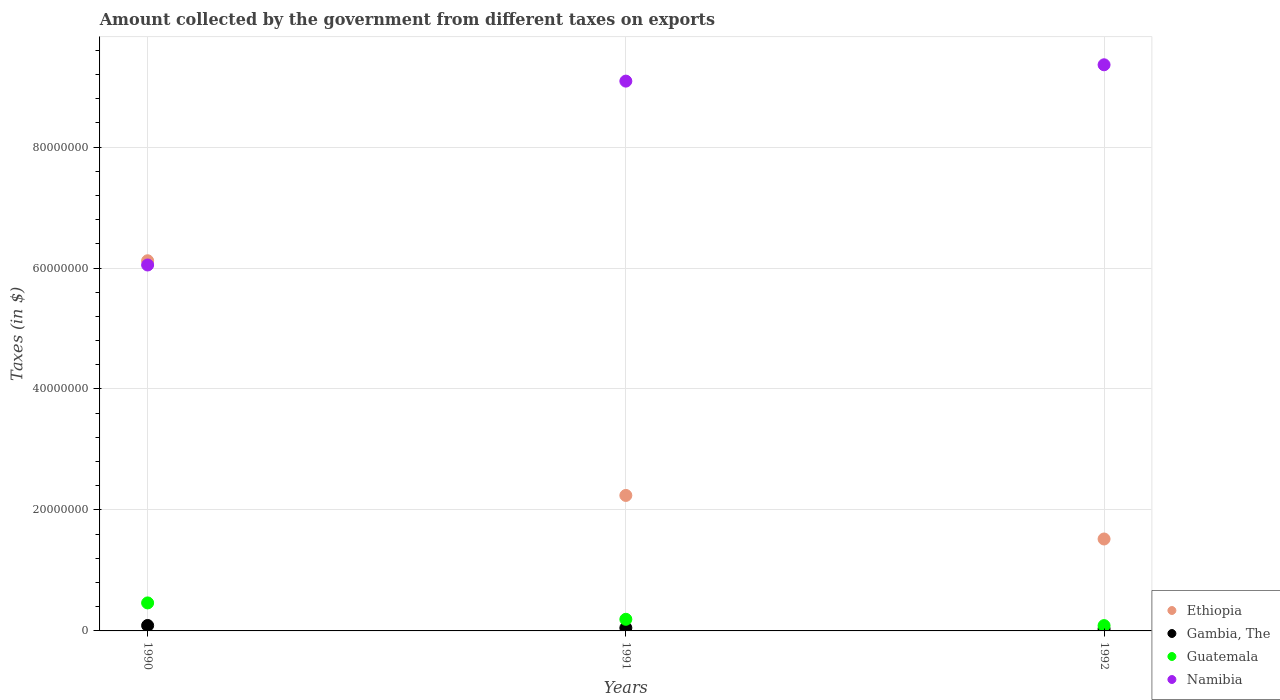Is the number of dotlines equal to the number of legend labels?
Provide a succinct answer. Yes. What is the amount collected by the government from taxes on exports in Ethiopia in 1990?
Make the answer very short. 6.12e+07. Across all years, what is the maximum amount collected by the government from taxes on exports in Gambia, The?
Give a very brief answer. 9.00e+05. Across all years, what is the minimum amount collected by the government from taxes on exports in Guatemala?
Your answer should be compact. 8.80e+05. In which year was the amount collected by the government from taxes on exports in Namibia maximum?
Keep it short and to the point. 1992. What is the total amount collected by the government from taxes on exports in Ethiopia in the graph?
Your response must be concise. 9.88e+07. What is the difference between the amount collected by the government from taxes on exports in Gambia, The in 1990 and that in 1991?
Your answer should be compact. 4.00e+05. What is the difference between the amount collected by the government from taxes on exports in Guatemala in 1992 and the amount collected by the government from taxes on exports in Namibia in 1990?
Keep it short and to the point. -5.96e+07. What is the average amount collected by the government from taxes on exports in Namibia per year?
Ensure brevity in your answer.  8.17e+07. In the year 1992, what is the difference between the amount collected by the government from taxes on exports in Guatemala and amount collected by the government from taxes on exports in Namibia?
Offer a terse response. -9.27e+07. What is the ratio of the amount collected by the government from taxes on exports in Namibia in 1990 to that in 1992?
Provide a succinct answer. 0.65. Is the difference between the amount collected by the government from taxes on exports in Guatemala in 1990 and 1991 greater than the difference between the amount collected by the government from taxes on exports in Namibia in 1990 and 1991?
Offer a terse response. Yes. What is the difference between the highest and the second highest amount collected by the government from taxes on exports in Namibia?
Your answer should be very brief. 2.70e+06. What is the difference between the highest and the lowest amount collected by the government from taxes on exports in Namibia?
Offer a very short reply. 3.31e+07. In how many years, is the amount collected by the government from taxes on exports in Guatemala greater than the average amount collected by the government from taxes on exports in Guatemala taken over all years?
Ensure brevity in your answer.  1. Is the sum of the amount collected by the government from taxes on exports in Namibia in 1990 and 1992 greater than the maximum amount collected by the government from taxes on exports in Gambia, The across all years?
Ensure brevity in your answer.  Yes. Is the amount collected by the government from taxes on exports in Ethiopia strictly greater than the amount collected by the government from taxes on exports in Namibia over the years?
Make the answer very short. No. Is the amount collected by the government from taxes on exports in Ethiopia strictly less than the amount collected by the government from taxes on exports in Namibia over the years?
Ensure brevity in your answer.  No. What is the difference between two consecutive major ticks on the Y-axis?
Your answer should be compact. 2.00e+07. Does the graph contain any zero values?
Your answer should be compact. No. What is the title of the graph?
Offer a very short reply. Amount collected by the government from different taxes on exports. What is the label or title of the Y-axis?
Your answer should be compact. Taxes (in $). What is the Taxes (in $) of Ethiopia in 1990?
Make the answer very short. 6.12e+07. What is the Taxes (in $) in Guatemala in 1990?
Provide a short and direct response. 4.63e+06. What is the Taxes (in $) of Namibia in 1990?
Ensure brevity in your answer.  6.05e+07. What is the Taxes (in $) in Ethiopia in 1991?
Make the answer very short. 2.24e+07. What is the Taxes (in $) of Gambia, The in 1991?
Provide a short and direct response. 5.00e+05. What is the Taxes (in $) in Guatemala in 1991?
Give a very brief answer. 1.92e+06. What is the Taxes (in $) of Namibia in 1991?
Offer a terse response. 9.09e+07. What is the Taxes (in $) of Ethiopia in 1992?
Offer a very short reply. 1.52e+07. What is the Taxes (in $) of Guatemala in 1992?
Provide a succinct answer. 8.80e+05. What is the Taxes (in $) in Namibia in 1992?
Your response must be concise. 9.36e+07. Across all years, what is the maximum Taxes (in $) of Ethiopia?
Provide a short and direct response. 6.12e+07. Across all years, what is the maximum Taxes (in $) of Guatemala?
Keep it short and to the point. 4.63e+06. Across all years, what is the maximum Taxes (in $) of Namibia?
Provide a short and direct response. 9.36e+07. Across all years, what is the minimum Taxes (in $) in Ethiopia?
Your answer should be compact. 1.52e+07. Across all years, what is the minimum Taxes (in $) of Guatemala?
Give a very brief answer. 8.80e+05. Across all years, what is the minimum Taxes (in $) of Namibia?
Your answer should be very brief. 6.05e+07. What is the total Taxes (in $) of Ethiopia in the graph?
Give a very brief answer. 9.88e+07. What is the total Taxes (in $) in Gambia, The in the graph?
Offer a very short reply. 1.72e+06. What is the total Taxes (in $) in Guatemala in the graph?
Give a very brief answer. 7.43e+06. What is the total Taxes (in $) of Namibia in the graph?
Provide a succinct answer. 2.45e+08. What is the difference between the Taxes (in $) in Ethiopia in 1990 and that in 1991?
Offer a very short reply. 3.88e+07. What is the difference between the Taxes (in $) in Gambia, The in 1990 and that in 1991?
Keep it short and to the point. 4.00e+05. What is the difference between the Taxes (in $) of Guatemala in 1990 and that in 1991?
Offer a very short reply. 2.71e+06. What is the difference between the Taxes (in $) of Namibia in 1990 and that in 1991?
Ensure brevity in your answer.  -3.04e+07. What is the difference between the Taxes (in $) in Ethiopia in 1990 and that in 1992?
Your answer should be compact. 4.60e+07. What is the difference between the Taxes (in $) of Gambia, The in 1990 and that in 1992?
Offer a terse response. 5.80e+05. What is the difference between the Taxes (in $) in Guatemala in 1990 and that in 1992?
Your response must be concise. 3.75e+06. What is the difference between the Taxes (in $) of Namibia in 1990 and that in 1992?
Provide a short and direct response. -3.31e+07. What is the difference between the Taxes (in $) of Ethiopia in 1991 and that in 1992?
Your answer should be compact. 7.20e+06. What is the difference between the Taxes (in $) in Gambia, The in 1991 and that in 1992?
Make the answer very short. 1.80e+05. What is the difference between the Taxes (in $) of Guatemala in 1991 and that in 1992?
Offer a very short reply. 1.04e+06. What is the difference between the Taxes (in $) of Namibia in 1991 and that in 1992?
Provide a succinct answer. -2.70e+06. What is the difference between the Taxes (in $) of Ethiopia in 1990 and the Taxes (in $) of Gambia, The in 1991?
Your answer should be very brief. 6.07e+07. What is the difference between the Taxes (in $) of Ethiopia in 1990 and the Taxes (in $) of Guatemala in 1991?
Offer a terse response. 5.93e+07. What is the difference between the Taxes (in $) in Ethiopia in 1990 and the Taxes (in $) in Namibia in 1991?
Provide a succinct answer. -2.97e+07. What is the difference between the Taxes (in $) in Gambia, The in 1990 and the Taxes (in $) in Guatemala in 1991?
Provide a short and direct response. -1.02e+06. What is the difference between the Taxes (in $) of Gambia, The in 1990 and the Taxes (in $) of Namibia in 1991?
Ensure brevity in your answer.  -9.00e+07. What is the difference between the Taxes (in $) of Guatemala in 1990 and the Taxes (in $) of Namibia in 1991?
Provide a succinct answer. -8.63e+07. What is the difference between the Taxes (in $) of Ethiopia in 1990 and the Taxes (in $) of Gambia, The in 1992?
Offer a very short reply. 6.09e+07. What is the difference between the Taxes (in $) in Ethiopia in 1990 and the Taxes (in $) in Guatemala in 1992?
Provide a succinct answer. 6.03e+07. What is the difference between the Taxes (in $) of Ethiopia in 1990 and the Taxes (in $) of Namibia in 1992?
Provide a succinct answer. -3.24e+07. What is the difference between the Taxes (in $) of Gambia, The in 1990 and the Taxes (in $) of Guatemala in 1992?
Your response must be concise. 2.00e+04. What is the difference between the Taxes (in $) in Gambia, The in 1990 and the Taxes (in $) in Namibia in 1992?
Offer a very short reply. -9.27e+07. What is the difference between the Taxes (in $) in Guatemala in 1990 and the Taxes (in $) in Namibia in 1992?
Your response must be concise. -8.90e+07. What is the difference between the Taxes (in $) in Ethiopia in 1991 and the Taxes (in $) in Gambia, The in 1992?
Make the answer very short. 2.21e+07. What is the difference between the Taxes (in $) of Ethiopia in 1991 and the Taxes (in $) of Guatemala in 1992?
Provide a succinct answer. 2.15e+07. What is the difference between the Taxes (in $) of Ethiopia in 1991 and the Taxes (in $) of Namibia in 1992?
Your answer should be very brief. -7.12e+07. What is the difference between the Taxes (in $) in Gambia, The in 1991 and the Taxes (in $) in Guatemala in 1992?
Ensure brevity in your answer.  -3.80e+05. What is the difference between the Taxes (in $) of Gambia, The in 1991 and the Taxes (in $) of Namibia in 1992?
Offer a very short reply. -9.31e+07. What is the difference between the Taxes (in $) of Guatemala in 1991 and the Taxes (in $) of Namibia in 1992?
Your answer should be compact. -9.17e+07. What is the average Taxes (in $) in Ethiopia per year?
Offer a terse response. 3.29e+07. What is the average Taxes (in $) in Gambia, The per year?
Offer a terse response. 5.73e+05. What is the average Taxes (in $) of Guatemala per year?
Your answer should be very brief. 2.48e+06. What is the average Taxes (in $) of Namibia per year?
Offer a very short reply. 8.17e+07. In the year 1990, what is the difference between the Taxes (in $) in Ethiopia and Taxes (in $) in Gambia, The?
Your answer should be compact. 6.03e+07. In the year 1990, what is the difference between the Taxes (in $) in Ethiopia and Taxes (in $) in Guatemala?
Your answer should be compact. 5.66e+07. In the year 1990, what is the difference between the Taxes (in $) of Gambia, The and Taxes (in $) of Guatemala?
Keep it short and to the point. -3.73e+06. In the year 1990, what is the difference between the Taxes (in $) of Gambia, The and Taxes (in $) of Namibia?
Offer a very short reply. -5.96e+07. In the year 1990, what is the difference between the Taxes (in $) of Guatemala and Taxes (in $) of Namibia?
Give a very brief answer. -5.59e+07. In the year 1991, what is the difference between the Taxes (in $) in Ethiopia and Taxes (in $) in Gambia, The?
Your answer should be compact. 2.19e+07. In the year 1991, what is the difference between the Taxes (in $) of Ethiopia and Taxes (in $) of Guatemala?
Your answer should be compact. 2.05e+07. In the year 1991, what is the difference between the Taxes (in $) in Ethiopia and Taxes (in $) in Namibia?
Ensure brevity in your answer.  -6.85e+07. In the year 1991, what is the difference between the Taxes (in $) of Gambia, The and Taxes (in $) of Guatemala?
Your response must be concise. -1.42e+06. In the year 1991, what is the difference between the Taxes (in $) of Gambia, The and Taxes (in $) of Namibia?
Give a very brief answer. -9.04e+07. In the year 1991, what is the difference between the Taxes (in $) in Guatemala and Taxes (in $) in Namibia?
Offer a very short reply. -8.90e+07. In the year 1992, what is the difference between the Taxes (in $) of Ethiopia and Taxes (in $) of Gambia, The?
Offer a very short reply. 1.49e+07. In the year 1992, what is the difference between the Taxes (in $) in Ethiopia and Taxes (in $) in Guatemala?
Keep it short and to the point. 1.43e+07. In the year 1992, what is the difference between the Taxes (in $) in Ethiopia and Taxes (in $) in Namibia?
Provide a short and direct response. -7.84e+07. In the year 1992, what is the difference between the Taxes (in $) of Gambia, The and Taxes (in $) of Guatemala?
Your answer should be very brief. -5.60e+05. In the year 1992, what is the difference between the Taxes (in $) of Gambia, The and Taxes (in $) of Namibia?
Offer a very short reply. -9.33e+07. In the year 1992, what is the difference between the Taxes (in $) in Guatemala and Taxes (in $) in Namibia?
Keep it short and to the point. -9.27e+07. What is the ratio of the Taxes (in $) in Ethiopia in 1990 to that in 1991?
Keep it short and to the point. 2.73. What is the ratio of the Taxes (in $) in Guatemala in 1990 to that in 1991?
Ensure brevity in your answer.  2.41. What is the ratio of the Taxes (in $) of Namibia in 1990 to that in 1991?
Keep it short and to the point. 0.67. What is the ratio of the Taxes (in $) in Ethiopia in 1990 to that in 1992?
Your answer should be compact. 4.03. What is the ratio of the Taxes (in $) in Gambia, The in 1990 to that in 1992?
Provide a succinct answer. 2.81. What is the ratio of the Taxes (in $) in Guatemala in 1990 to that in 1992?
Provide a short and direct response. 5.26. What is the ratio of the Taxes (in $) in Namibia in 1990 to that in 1992?
Make the answer very short. 0.65. What is the ratio of the Taxes (in $) in Ethiopia in 1991 to that in 1992?
Your response must be concise. 1.47. What is the ratio of the Taxes (in $) in Gambia, The in 1991 to that in 1992?
Make the answer very short. 1.56. What is the ratio of the Taxes (in $) in Guatemala in 1991 to that in 1992?
Keep it short and to the point. 2.18. What is the ratio of the Taxes (in $) in Namibia in 1991 to that in 1992?
Make the answer very short. 0.97. What is the difference between the highest and the second highest Taxes (in $) of Ethiopia?
Provide a succinct answer. 3.88e+07. What is the difference between the highest and the second highest Taxes (in $) in Gambia, The?
Your response must be concise. 4.00e+05. What is the difference between the highest and the second highest Taxes (in $) of Guatemala?
Make the answer very short. 2.71e+06. What is the difference between the highest and the second highest Taxes (in $) of Namibia?
Ensure brevity in your answer.  2.70e+06. What is the difference between the highest and the lowest Taxes (in $) of Ethiopia?
Your response must be concise. 4.60e+07. What is the difference between the highest and the lowest Taxes (in $) in Gambia, The?
Provide a succinct answer. 5.80e+05. What is the difference between the highest and the lowest Taxes (in $) in Guatemala?
Provide a short and direct response. 3.75e+06. What is the difference between the highest and the lowest Taxes (in $) in Namibia?
Provide a short and direct response. 3.31e+07. 